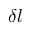Convert formula to latex. <formula><loc_0><loc_0><loc_500><loc_500>\delta l</formula> 